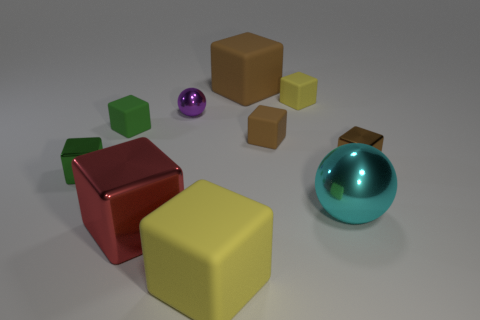How many brown cubes must be subtracted to get 1 brown cubes? 2 Subtract all brown shiny cubes. How many cubes are left? 7 Subtract all balls. How many objects are left? 8 Subtract all brown cylinders. How many green cubes are left? 2 Add 3 big blue metallic objects. How many big blue metallic objects exist? 3 Subtract all purple spheres. How many spheres are left? 1 Subtract 0 gray spheres. How many objects are left? 10 Subtract 1 balls. How many balls are left? 1 Subtract all cyan spheres. Subtract all yellow cubes. How many spheres are left? 1 Subtract all big brown things. Subtract all tiny green shiny blocks. How many objects are left? 8 